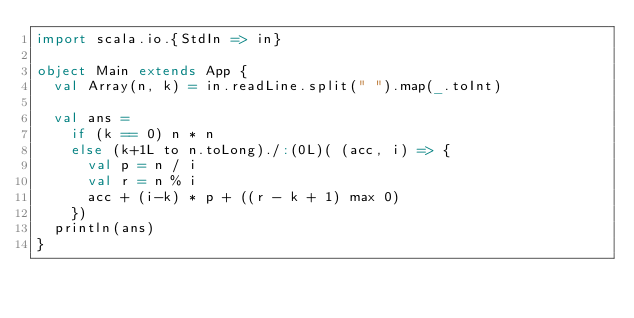<code> <loc_0><loc_0><loc_500><loc_500><_Scala_>import scala.io.{StdIn => in}

object Main extends App {
  val Array(n, k) = in.readLine.split(" ").map(_.toInt)

  val ans = 
    if (k == 0) n * n
    else (k+1L to n.toLong)./:(0L)( (acc, i) => {
      val p = n / i
      val r = n % i
      acc + (i-k) * p + ((r - k + 1) max 0)
    })
  println(ans)
}</code> 